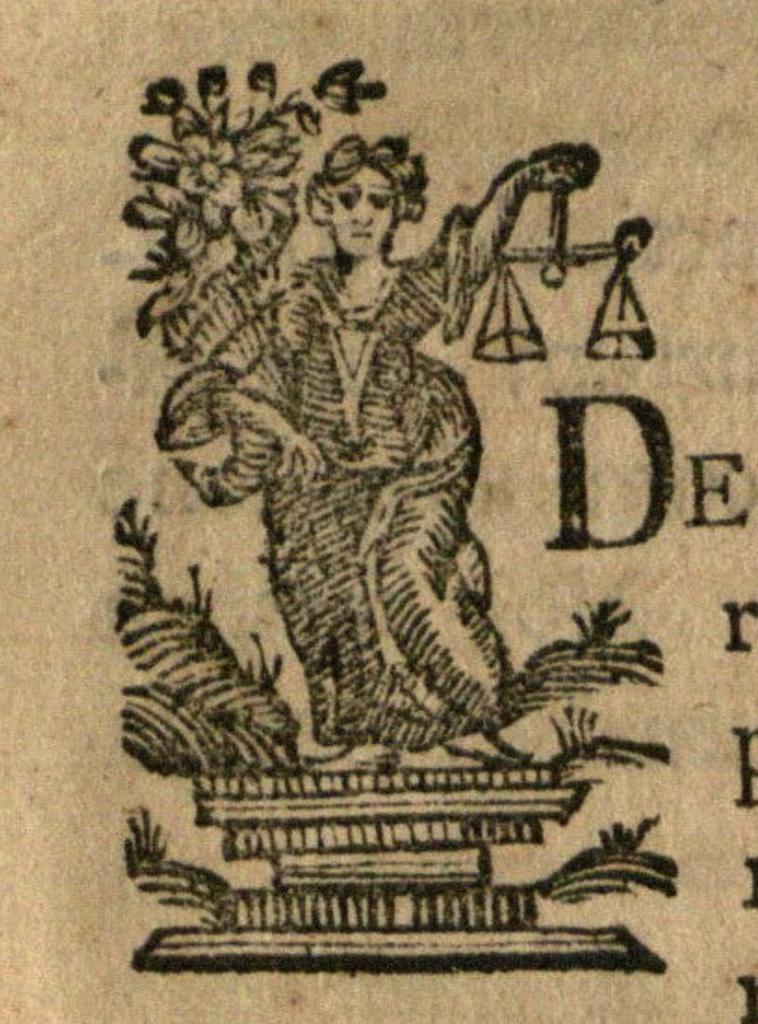<image>
Render a clear and concise summary of the photo. The letter D appears to the right of a woman holding scales. 